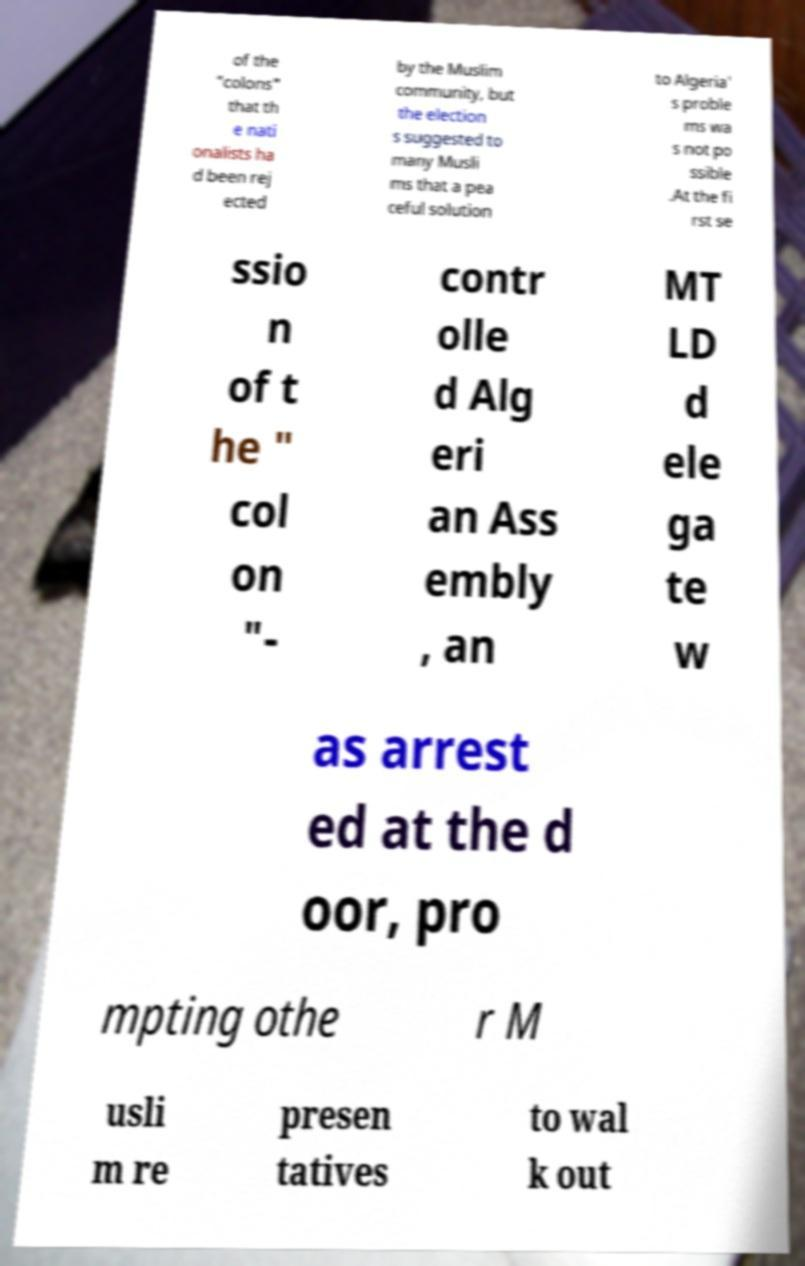For documentation purposes, I need the text within this image transcribed. Could you provide that? of the "colons" that th e nati onalists ha d been rej ected by the Muslim community, but the election s suggested to many Musli ms that a pea ceful solution to Algeria' s proble ms wa s not po ssible .At the fi rst se ssio n of t he " col on "- contr olle d Alg eri an Ass embly , an MT LD d ele ga te w as arrest ed at the d oor, pro mpting othe r M usli m re presen tatives to wal k out 